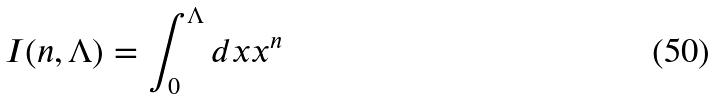<formula> <loc_0><loc_0><loc_500><loc_500>I ( n , \Lambda ) = \int _ { 0 } ^ { \Lambda } d x x ^ { n }</formula> 